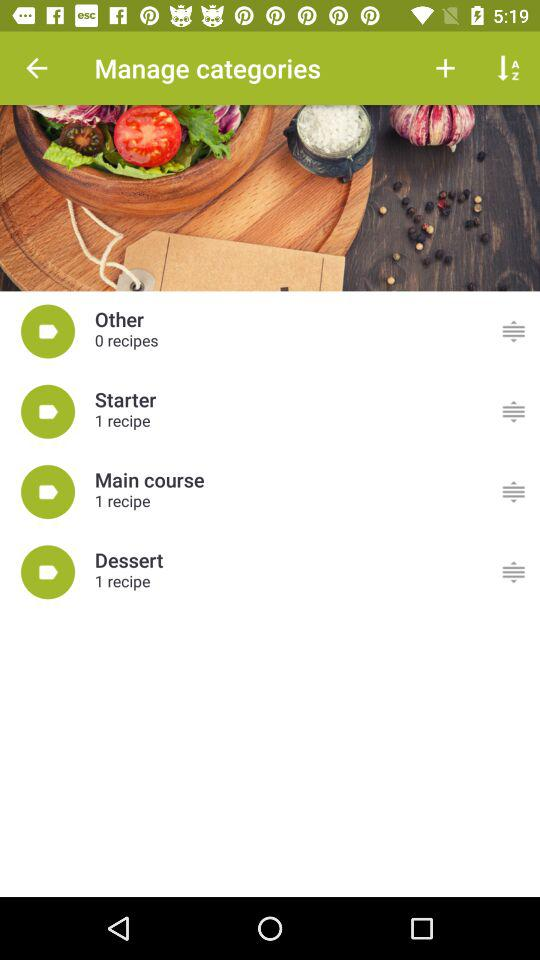How many recipes are there in total?
Answer the question using a single word or phrase. 3 